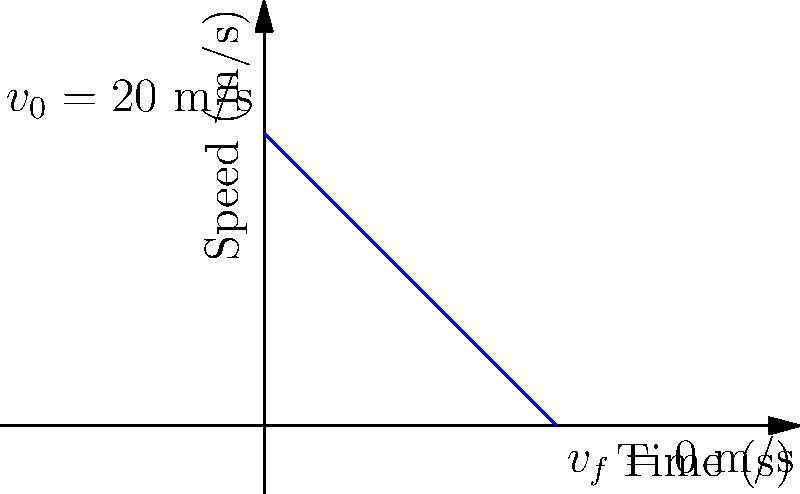As a defensive driving instructor, you're teaching about stopping distances. The graph shows a vehicle's deceleration from 20 m/s to a complete stop over 20 seconds. Calculate the total distance traveled by the vehicle during this deceleration period. Let's approach this step-by-step:

1) The graph shows a linear relationship between speed and time, which indicates constant deceleration.

2) In such cases, the distance traveled is equal to the area under the speed-time graph.

3) The graph forms a right triangle. We can calculate its area to find the distance traveled.

4) The base of the triangle is 20 seconds (time taken to stop).

5) The height of the triangle is 20 m/s (initial speed).

6) Area of a triangle = $\frac{1}{2} \times base \times height$

7) Distance = $\frac{1}{2} \times 20 \text{ s} \times 20 \text{ m/s}$

8) Distance = $200 \text{ m}$

Therefore, the vehicle travels 200 meters during its deceleration period.
Answer: 200 m 